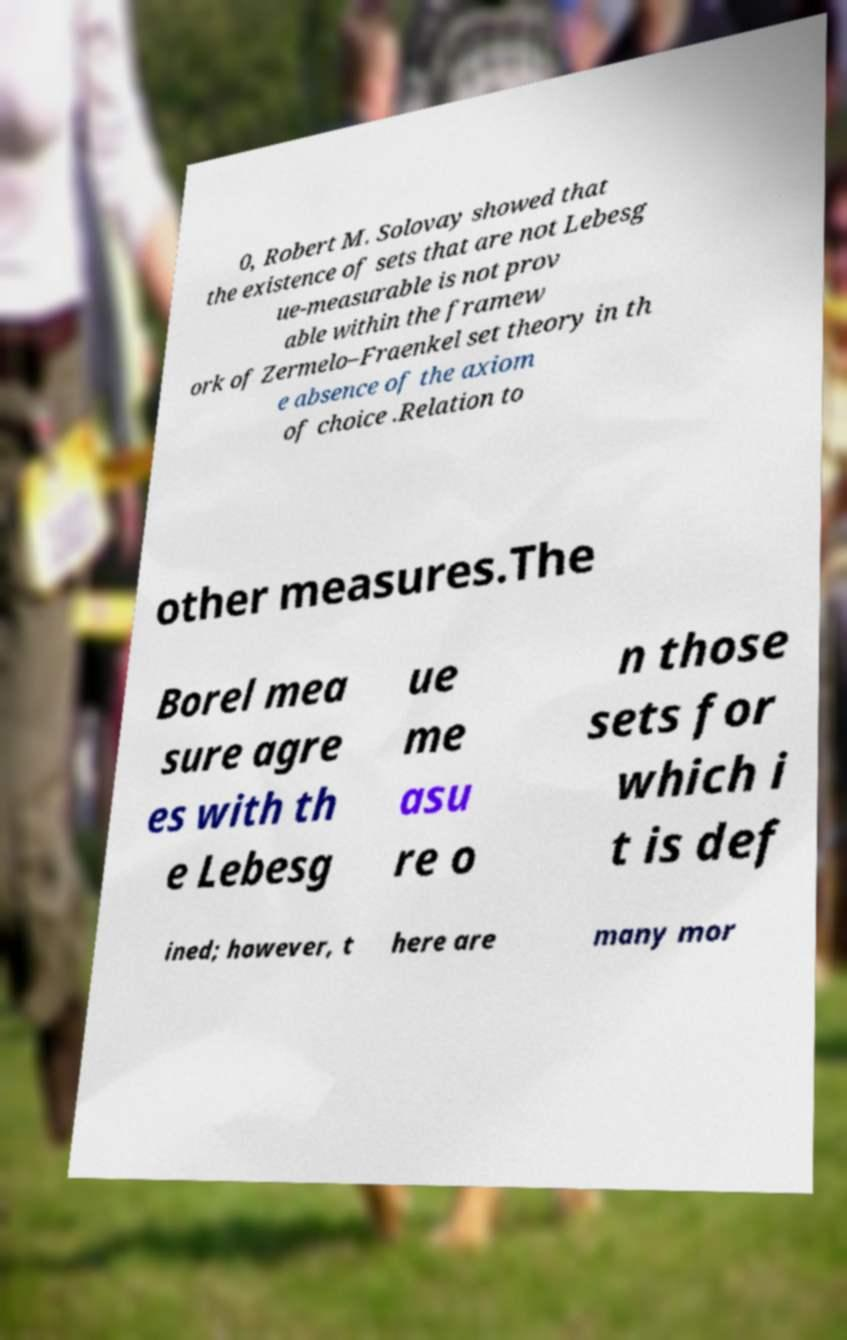Can you accurately transcribe the text from the provided image for me? 0, Robert M. Solovay showed that the existence of sets that are not Lebesg ue-measurable is not prov able within the framew ork of Zermelo–Fraenkel set theory in th e absence of the axiom of choice .Relation to other measures.The Borel mea sure agre es with th e Lebesg ue me asu re o n those sets for which i t is def ined; however, t here are many mor 